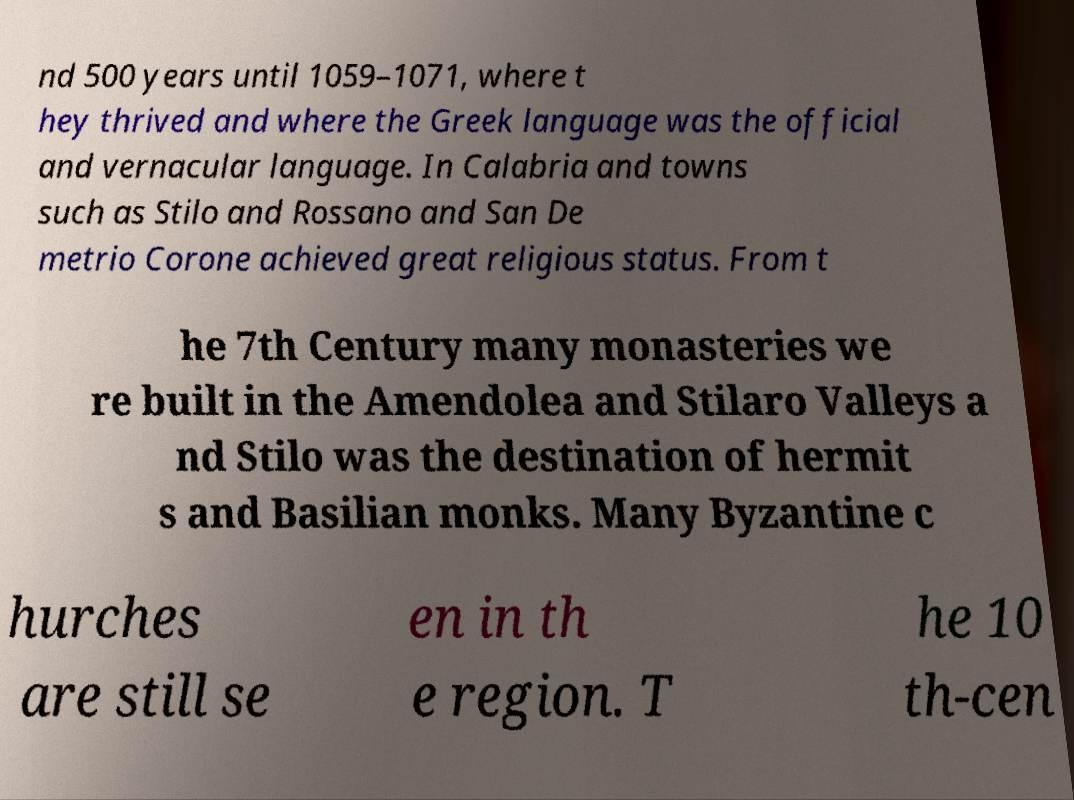For documentation purposes, I need the text within this image transcribed. Could you provide that? nd 500 years until 1059–1071, where t hey thrived and where the Greek language was the official and vernacular language. In Calabria and towns such as Stilo and Rossano and San De metrio Corone achieved great religious status. From t he 7th Century many monasteries we re built in the Amendolea and Stilaro Valleys a nd Stilo was the destination of hermit s and Basilian monks. Many Byzantine c hurches are still se en in th e region. T he 10 th-cen 